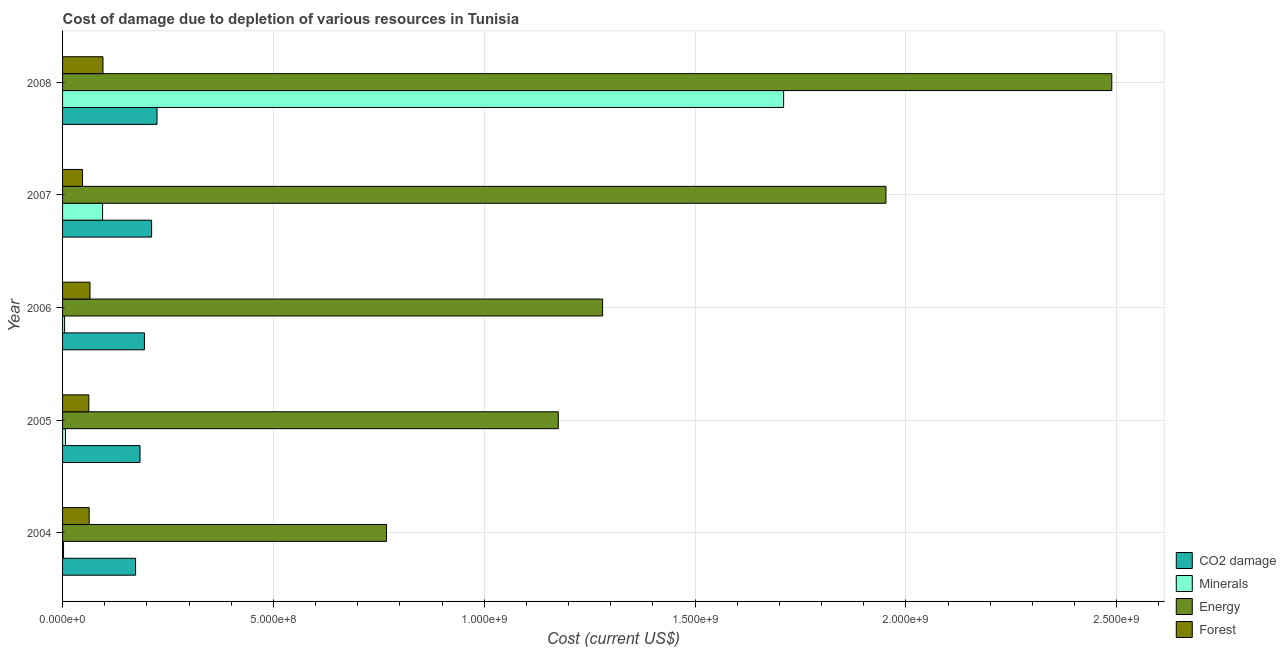How many groups of bars are there?
Offer a terse response. 5. Are the number of bars per tick equal to the number of legend labels?
Provide a short and direct response. Yes. Are the number of bars on each tick of the Y-axis equal?
Provide a succinct answer. Yes. What is the cost of damage due to depletion of coal in 2007?
Provide a short and direct response. 2.11e+08. Across all years, what is the maximum cost of damage due to depletion of forests?
Offer a very short reply. 9.59e+07. Across all years, what is the minimum cost of damage due to depletion of energy?
Offer a very short reply. 7.68e+08. What is the total cost of damage due to depletion of forests in the graph?
Provide a succinct answer. 3.34e+08. What is the difference between the cost of damage due to depletion of forests in 2005 and that in 2007?
Your answer should be compact. 1.49e+07. What is the difference between the cost of damage due to depletion of energy in 2005 and the cost of damage due to depletion of minerals in 2004?
Offer a terse response. 1.17e+09. What is the average cost of damage due to depletion of coal per year?
Your answer should be very brief. 1.97e+08. In the year 2004, what is the difference between the cost of damage due to depletion of forests and cost of damage due to depletion of minerals?
Offer a very short reply. 6.08e+07. In how many years, is the cost of damage due to depletion of forests greater than 700000000 US$?
Provide a short and direct response. 0. What is the ratio of the cost of damage due to depletion of coal in 2004 to that in 2006?
Your answer should be very brief. 0.89. Is the cost of damage due to depletion of coal in 2004 less than that in 2006?
Your answer should be compact. Yes. Is the difference between the cost of damage due to depletion of minerals in 2006 and 2008 greater than the difference between the cost of damage due to depletion of coal in 2006 and 2008?
Offer a terse response. No. What is the difference between the highest and the second highest cost of damage due to depletion of forests?
Provide a succinct answer. 3.08e+07. What is the difference between the highest and the lowest cost of damage due to depletion of coal?
Provide a short and direct response. 5.08e+07. In how many years, is the cost of damage due to depletion of forests greater than the average cost of damage due to depletion of forests taken over all years?
Keep it short and to the point. 1. Is the sum of the cost of damage due to depletion of coal in 2006 and 2008 greater than the maximum cost of damage due to depletion of energy across all years?
Ensure brevity in your answer.  No. Is it the case that in every year, the sum of the cost of damage due to depletion of forests and cost of damage due to depletion of energy is greater than the sum of cost of damage due to depletion of coal and cost of damage due to depletion of minerals?
Your answer should be very brief. Yes. What does the 3rd bar from the top in 2005 represents?
Provide a succinct answer. Minerals. What does the 2nd bar from the bottom in 2007 represents?
Offer a terse response. Minerals. How many bars are there?
Provide a short and direct response. 20. What is the title of the graph?
Provide a short and direct response. Cost of damage due to depletion of various resources in Tunisia . What is the label or title of the X-axis?
Keep it short and to the point. Cost (current US$). What is the label or title of the Y-axis?
Give a very brief answer. Year. What is the Cost (current US$) in CO2 damage in 2004?
Give a very brief answer. 1.73e+08. What is the Cost (current US$) of Minerals in 2004?
Your answer should be compact. 2.32e+06. What is the Cost (current US$) of Energy in 2004?
Your answer should be compact. 7.68e+08. What is the Cost (current US$) in Forest in 2004?
Offer a terse response. 6.31e+07. What is the Cost (current US$) in CO2 damage in 2005?
Make the answer very short. 1.84e+08. What is the Cost (current US$) of Minerals in 2005?
Provide a succinct answer. 6.94e+06. What is the Cost (current US$) in Energy in 2005?
Make the answer very short. 1.18e+09. What is the Cost (current US$) in Forest in 2005?
Offer a very short reply. 6.23e+07. What is the Cost (current US$) in CO2 damage in 2006?
Your answer should be very brief. 1.94e+08. What is the Cost (current US$) of Minerals in 2006?
Your answer should be compact. 4.85e+06. What is the Cost (current US$) of Energy in 2006?
Provide a succinct answer. 1.28e+09. What is the Cost (current US$) of Forest in 2006?
Your answer should be very brief. 6.51e+07. What is the Cost (current US$) of CO2 damage in 2007?
Offer a terse response. 2.11e+08. What is the Cost (current US$) in Minerals in 2007?
Give a very brief answer. 9.48e+07. What is the Cost (current US$) in Energy in 2007?
Offer a very short reply. 1.95e+09. What is the Cost (current US$) in Forest in 2007?
Offer a terse response. 4.74e+07. What is the Cost (current US$) of CO2 damage in 2008?
Offer a terse response. 2.24e+08. What is the Cost (current US$) in Minerals in 2008?
Keep it short and to the point. 1.71e+09. What is the Cost (current US$) of Energy in 2008?
Ensure brevity in your answer.  2.49e+09. What is the Cost (current US$) of Forest in 2008?
Provide a short and direct response. 9.59e+07. Across all years, what is the maximum Cost (current US$) of CO2 damage?
Give a very brief answer. 2.24e+08. Across all years, what is the maximum Cost (current US$) in Minerals?
Provide a succinct answer. 1.71e+09. Across all years, what is the maximum Cost (current US$) in Energy?
Offer a very short reply. 2.49e+09. Across all years, what is the maximum Cost (current US$) of Forest?
Provide a short and direct response. 9.59e+07. Across all years, what is the minimum Cost (current US$) of CO2 damage?
Offer a very short reply. 1.73e+08. Across all years, what is the minimum Cost (current US$) in Minerals?
Your response must be concise. 2.32e+06. Across all years, what is the minimum Cost (current US$) in Energy?
Offer a terse response. 7.68e+08. Across all years, what is the minimum Cost (current US$) in Forest?
Ensure brevity in your answer.  4.74e+07. What is the total Cost (current US$) of CO2 damage in the graph?
Ensure brevity in your answer.  9.86e+08. What is the total Cost (current US$) in Minerals in the graph?
Provide a short and direct response. 1.82e+09. What is the total Cost (current US$) of Energy in the graph?
Give a very brief answer. 7.67e+09. What is the total Cost (current US$) in Forest in the graph?
Your answer should be compact. 3.34e+08. What is the difference between the Cost (current US$) in CO2 damage in 2004 and that in 2005?
Offer a very short reply. -1.05e+07. What is the difference between the Cost (current US$) in Minerals in 2004 and that in 2005?
Provide a short and direct response. -4.63e+06. What is the difference between the Cost (current US$) of Energy in 2004 and that in 2005?
Offer a terse response. -4.07e+08. What is the difference between the Cost (current US$) of Forest in 2004 and that in 2005?
Make the answer very short. 8.33e+05. What is the difference between the Cost (current US$) of CO2 damage in 2004 and that in 2006?
Offer a terse response. -2.09e+07. What is the difference between the Cost (current US$) of Minerals in 2004 and that in 2006?
Keep it short and to the point. -2.53e+06. What is the difference between the Cost (current US$) of Energy in 2004 and that in 2006?
Keep it short and to the point. -5.13e+08. What is the difference between the Cost (current US$) in Forest in 2004 and that in 2006?
Keep it short and to the point. -1.98e+06. What is the difference between the Cost (current US$) in CO2 damage in 2004 and that in 2007?
Your response must be concise. -3.80e+07. What is the difference between the Cost (current US$) in Minerals in 2004 and that in 2007?
Provide a succinct answer. -9.25e+07. What is the difference between the Cost (current US$) of Energy in 2004 and that in 2007?
Offer a very short reply. -1.18e+09. What is the difference between the Cost (current US$) in Forest in 2004 and that in 2007?
Your answer should be compact. 1.57e+07. What is the difference between the Cost (current US$) of CO2 damage in 2004 and that in 2008?
Your answer should be very brief. -5.08e+07. What is the difference between the Cost (current US$) of Minerals in 2004 and that in 2008?
Offer a very short reply. -1.71e+09. What is the difference between the Cost (current US$) of Energy in 2004 and that in 2008?
Make the answer very short. -1.72e+09. What is the difference between the Cost (current US$) in Forest in 2004 and that in 2008?
Your answer should be compact. -3.28e+07. What is the difference between the Cost (current US$) in CO2 damage in 2005 and that in 2006?
Your answer should be very brief. -1.04e+07. What is the difference between the Cost (current US$) in Minerals in 2005 and that in 2006?
Ensure brevity in your answer.  2.10e+06. What is the difference between the Cost (current US$) in Energy in 2005 and that in 2006?
Ensure brevity in your answer.  -1.05e+08. What is the difference between the Cost (current US$) in Forest in 2005 and that in 2006?
Ensure brevity in your answer.  -2.81e+06. What is the difference between the Cost (current US$) in CO2 damage in 2005 and that in 2007?
Your answer should be very brief. -2.75e+07. What is the difference between the Cost (current US$) in Minerals in 2005 and that in 2007?
Make the answer very short. -8.79e+07. What is the difference between the Cost (current US$) of Energy in 2005 and that in 2007?
Give a very brief answer. -7.77e+08. What is the difference between the Cost (current US$) of Forest in 2005 and that in 2007?
Give a very brief answer. 1.49e+07. What is the difference between the Cost (current US$) of CO2 damage in 2005 and that in 2008?
Keep it short and to the point. -4.03e+07. What is the difference between the Cost (current US$) of Minerals in 2005 and that in 2008?
Offer a terse response. -1.70e+09. What is the difference between the Cost (current US$) in Energy in 2005 and that in 2008?
Provide a short and direct response. -1.31e+09. What is the difference between the Cost (current US$) of Forest in 2005 and that in 2008?
Give a very brief answer. -3.36e+07. What is the difference between the Cost (current US$) of CO2 damage in 2006 and that in 2007?
Give a very brief answer. -1.71e+07. What is the difference between the Cost (current US$) in Minerals in 2006 and that in 2007?
Keep it short and to the point. -9.00e+07. What is the difference between the Cost (current US$) in Energy in 2006 and that in 2007?
Give a very brief answer. -6.72e+08. What is the difference between the Cost (current US$) in Forest in 2006 and that in 2007?
Provide a short and direct response. 1.77e+07. What is the difference between the Cost (current US$) in CO2 damage in 2006 and that in 2008?
Ensure brevity in your answer.  -2.99e+07. What is the difference between the Cost (current US$) in Minerals in 2006 and that in 2008?
Make the answer very short. -1.71e+09. What is the difference between the Cost (current US$) in Energy in 2006 and that in 2008?
Offer a very short reply. -1.21e+09. What is the difference between the Cost (current US$) in Forest in 2006 and that in 2008?
Provide a short and direct response. -3.08e+07. What is the difference between the Cost (current US$) of CO2 damage in 2007 and that in 2008?
Make the answer very short. -1.29e+07. What is the difference between the Cost (current US$) in Minerals in 2007 and that in 2008?
Your answer should be very brief. -1.62e+09. What is the difference between the Cost (current US$) of Energy in 2007 and that in 2008?
Offer a very short reply. -5.36e+08. What is the difference between the Cost (current US$) of Forest in 2007 and that in 2008?
Your answer should be very brief. -4.85e+07. What is the difference between the Cost (current US$) of CO2 damage in 2004 and the Cost (current US$) of Minerals in 2005?
Give a very brief answer. 1.66e+08. What is the difference between the Cost (current US$) in CO2 damage in 2004 and the Cost (current US$) in Energy in 2005?
Make the answer very short. -1.00e+09. What is the difference between the Cost (current US$) of CO2 damage in 2004 and the Cost (current US$) of Forest in 2005?
Provide a short and direct response. 1.11e+08. What is the difference between the Cost (current US$) in Minerals in 2004 and the Cost (current US$) in Energy in 2005?
Provide a succinct answer. -1.17e+09. What is the difference between the Cost (current US$) in Minerals in 2004 and the Cost (current US$) in Forest in 2005?
Provide a short and direct response. -5.99e+07. What is the difference between the Cost (current US$) of Energy in 2004 and the Cost (current US$) of Forest in 2005?
Give a very brief answer. 7.06e+08. What is the difference between the Cost (current US$) of CO2 damage in 2004 and the Cost (current US$) of Minerals in 2006?
Your answer should be compact. 1.68e+08. What is the difference between the Cost (current US$) of CO2 damage in 2004 and the Cost (current US$) of Energy in 2006?
Offer a very short reply. -1.11e+09. What is the difference between the Cost (current US$) in CO2 damage in 2004 and the Cost (current US$) in Forest in 2006?
Offer a very short reply. 1.08e+08. What is the difference between the Cost (current US$) in Minerals in 2004 and the Cost (current US$) in Energy in 2006?
Provide a succinct answer. -1.28e+09. What is the difference between the Cost (current US$) of Minerals in 2004 and the Cost (current US$) of Forest in 2006?
Your answer should be very brief. -6.27e+07. What is the difference between the Cost (current US$) of Energy in 2004 and the Cost (current US$) of Forest in 2006?
Your response must be concise. 7.03e+08. What is the difference between the Cost (current US$) in CO2 damage in 2004 and the Cost (current US$) in Minerals in 2007?
Provide a short and direct response. 7.84e+07. What is the difference between the Cost (current US$) of CO2 damage in 2004 and the Cost (current US$) of Energy in 2007?
Your answer should be compact. -1.78e+09. What is the difference between the Cost (current US$) in CO2 damage in 2004 and the Cost (current US$) in Forest in 2007?
Make the answer very short. 1.26e+08. What is the difference between the Cost (current US$) of Minerals in 2004 and the Cost (current US$) of Energy in 2007?
Keep it short and to the point. -1.95e+09. What is the difference between the Cost (current US$) in Minerals in 2004 and the Cost (current US$) in Forest in 2007?
Make the answer very short. -4.51e+07. What is the difference between the Cost (current US$) in Energy in 2004 and the Cost (current US$) in Forest in 2007?
Your answer should be very brief. 7.21e+08. What is the difference between the Cost (current US$) of CO2 damage in 2004 and the Cost (current US$) of Minerals in 2008?
Provide a short and direct response. -1.54e+09. What is the difference between the Cost (current US$) of CO2 damage in 2004 and the Cost (current US$) of Energy in 2008?
Your response must be concise. -2.32e+09. What is the difference between the Cost (current US$) in CO2 damage in 2004 and the Cost (current US$) in Forest in 2008?
Offer a terse response. 7.73e+07. What is the difference between the Cost (current US$) of Minerals in 2004 and the Cost (current US$) of Energy in 2008?
Provide a succinct answer. -2.49e+09. What is the difference between the Cost (current US$) of Minerals in 2004 and the Cost (current US$) of Forest in 2008?
Your answer should be compact. -9.35e+07. What is the difference between the Cost (current US$) of Energy in 2004 and the Cost (current US$) of Forest in 2008?
Offer a terse response. 6.72e+08. What is the difference between the Cost (current US$) of CO2 damage in 2005 and the Cost (current US$) of Minerals in 2006?
Offer a very short reply. 1.79e+08. What is the difference between the Cost (current US$) in CO2 damage in 2005 and the Cost (current US$) in Energy in 2006?
Keep it short and to the point. -1.10e+09. What is the difference between the Cost (current US$) of CO2 damage in 2005 and the Cost (current US$) of Forest in 2006?
Make the answer very short. 1.19e+08. What is the difference between the Cost (current US$) of Minerals in 2005 and the Cost (current US$) of Energy in 2006?
Offer a terse response. -1.27e+09. What is the difference between the Cost (current US$) in Minerals in 2005 and the Cost (current US$) in Forest in 2006?
Keep it short and to the point. -5.81e+07. What is the difference between the Cost (current US$) of Energy in 2005 and the Cost (current US$) of Forest in 2006?
Make the answer very short. 1.11e+09. What is the difference between the Cost (current US$) of CO2 damage in 2005 and the Cost (current US$) of Minerals in 2007?
Keep it short and to the point. 8.88e+07. What is the difference between the Cost (current US$) in CO2 damage in 2005 and the Cost (current US$) in Energy in 2007?
Offer a terse response. -1.77e+09. What is the difference between the Cost (current US$) in CO2 damage in 2005 and the Cost (current US$) in Forest in 2007?
Ensure brevity in your answer.  1.36e+08. What is the difference between the Cost (current US$) in Minerals in 2005 and the Cost (current US$) in Energy in 2007?
Give a very brief answer. -1.95e+09. What is the difference between the Cost (current US$) of Minerals in 2005 and the Cost (current US$) of Forest in 2007?
Your answer should be very brief. -4.04e+07. What is the difference between the Cost (current US$) of Energy in 2005 and the Cost (current US$) of Forest in 2007?
Ensure brevity in your answer.  1.13e+09. What is the difference between the Cost (current US$) in CO2 damage in 2005 and the Cost (current US$) in Minerals in 2008?
Give a very brief answer. -1.53e+09. What is the difference between the Cost (current US$) of CO2 damage in 2005 and the Cost (current US$) of Energy in 2008?
Offer a terse response. -2.30e+09. What is the difference between the Cost (current US$) of CO2 damage in 2005 and the Cost (current US$) of Forest in 2008?
Give a very brief answer. 8.78e+07. What is the difference between the Cost (current US$) of Minerals in 2005 and the Cost (current US$) of Energy in 2008?
Your answer should be compact. -2.48e+09. What is the difference between the Cost (current US$) of Minerals in 2005 and the Cost (current US$) of Forest in 2008?
Give a very brief answer. -8.89e+07. What is the difference between the Cost (current US$) in Energy in 2005 and the Cost (current US$) in Forest in 2008?
Your answer should be very brief. 1.08e+09. What is the difference between the Cost (current US$) in CO2 damage in 2006 and the Cost (current US$) in Minerals in 2007?
Make the answer very short. 9.93e+07. What is the difference between the Cost (current US$) of CO2 damage in 2006 and the Cost (current US$) of Energy in 2007?
Keep it short and to the point. -1.76e+09. What is the difference between the Cost (current US$) in CO2 damage in 2006 and the Cost (current US$) in Forest in 2007?
Offer a terse response. 1.47e+08. What is the difference between the Cost (current US$) in Minerals in 2006 and the Cost (current US$) in Energy in 2007?
Provide a succinct answer. -1.95e+09. What is the difference between the Cost (current US$) of Minerals in 2006 and the Cost (current US$) of Forest in 2007?
Keep it short and to the point. -4.25e+07. What is the difference between the Cost (current US$) of Energy in 2006 and the Cost (current US$) of Forest in 2007?
Make the answer very short. 1.23e+09. What is the difference between the Cost (current US$) in CO2 damage in 2006 and the Cost (current US$) in Minerals in 2008?
Offer a very short reply. -1.52e+09. What is the difference between the Cost (current US$) in CO2 damage in 2006 and the Cost (current US$) in Energy in 2008?
Ensure brevity in your answer.  -2.29e+09. What is the difference between the Cost (current US$) in CO2 damage in 2006 and the Cost (current US$) in Forest in 2008?
Offer a very short reply. 9.82e+07. What is the difference between the Cost (current US$) of Minerals in 2006 and the Cost (current US$) of Energy in 2008?
Make the answer very short. -2.48e+09. What is the difference between the Cost (current US$) of Minerals in 2006 and the Cost (current US$) of Forest in 2008?
Keep it short and to the point. -9.10e+07. What is the difference between the Cost (current US$) of Energy in 2006 and the Cost (current US$) of Forest in 2008?
Your response must be concise. 1.18e+09. What is the difference between the Cost (current US$) of CO2 damage in 2007 and the Cost (current US$) of Minerals in 2008?
Provide a succinct answer. -1.50e+09. What is the difference between the Cost (current US$) of CO2 damage in 2007 and the Cost (current US$) of Energy in 2008?
Your response must be concise. -2.28e+09. What is the difference between the Cost (current US$) in CO2 damage in 2007 and the Cost (current US$) in Forest in 2008?
Your response must be concise. 1.15e+08. What is the difference between the Cost (current US$) in Minerals in 2007 and the Cost (current US$) in Energy in 2008?
Your response must be concise. -2.39e+09. What is the difference between the Cost (current US$) in Minerals in 2007 and the Cost (current US$) in Forest in 2008?
Provide a succinct answer. -1.02e+06. What is the difference between the Cost (current US$) of Energy in 2007 and the Cost (current US$) of Forest in 2008?
Your answer should be compact. 1.86e+09. What is the average Cost (current US$) in CO2 damage per year?
Provide a short and direct response. 1.97e+08. What is the average Cost (current US$) in Minerals per year?
Offer a very short reply. 3.64e+08. What is the average Cost (current US$) in Energy per year?
Offer a very short reply. 1.53e+09. What is the average Cost (current US$) in Forest per year?
Your answer should be very brief. 6.67e+07. In the year 2004, what is the difference between the Cost (current US$) of CO2 damage and Cost (current US$) of Minerals?
Ensure brevity in your answer.  1.71e+08. In the year 2004, what is the difference between the Cost (current US$) of CO2 damage and Cost (current US$) of Energy?
Provide a short and direct response. -5.95e+08. In the year 2004, what is the difference between the Cost (current US$) in CO2 damage and Cost (current US$) in Forest?
Make the answer very short. 1.10e+08. In the year 2004, what is the difference between the Cost (current US$) in Minerals and Cost (current US$) in Energy?
Give a very brief answer. -7.66e+08. In the year 2004, what is the difference between the Cost (current US$) in Minerals and Cost (current US$) in Forest?
Provide a short and direct response. -6.08e+07. In the year 2004, what is the difference between the Cost (current US$) of Energy and Cost (current US$) of Forest?
Give a very brief answer. 7.05e+08. In the year 2005, what is the difference between the Cost (current US$) of CO2 damage and Cost (current US$) of Minerals?
Your response must be concise. 1.77e+08. In the year 2005, what is the difference between the Cost (current US$) in CO2 damage and Cost (current US$) in Energy?
Provide a short and direct response. -9.92e+08. In the year 2005, what is the difference between the Cost (current US$) in CO2 damage and Cost (current US$) in Forest?
Make the answer very short. 1.21e+08. In the year 2005, what is the difference between the Cost (current US$) of Minerals and Cost (current US$) of Energy?
Provide a short and direct response. -1.17e+09. In the year 2005, what is the difference between the Cost (current US$) of Minerals and Cost (current US$) of Forest?
Ensure brevity in your answer.  -5.53e+07. In the year 2005, what is the difference between the Cost (current US$) of Energy and Cost (current US$) of Forest?
Keep it short and to the point. 1.11e+09. In the year 2006, what is the difference between the Cost (current US$) in CO2 damage and Cost (current US$) in Minerals?
Offer a very short reply. 1.89e+08. In the year 2006, what is the difference between the Cost (current US$) in CO2 damage and Cost (current US$) in Energy?
Provide a short and direct response. -1.09e+09. In the year 2006, what is the difference between the Cost (current US$) of CO2 damage and Cost (current US$) of Forest?
Provide a succinct answer. 1.29e+08. In the year 2006, what is the difference between the Cost (current US$) in Minerals and Cost (current US$) in Energy?
Provide a succinct answer. -1.28e+09. In the year 2006, what is the difference between the Cost (current US$) in Minerals and Cost (current US$) in Forest?
Give a very brief answer. -6.02e+07. In the year 2006, what is the difference between the Cost (current US$) of Energy and Cost (current US$) of Forest?
Provide a short and direct response. 1.22e+09. In the year 2007, what is the difference between the Cost (current US$) in CO2 damage and Cost (current US$) in Minerals?
Give a very brief answer. 1.16e+08. In the year 2007, what is the difference between the Cost (current US$) in CO2 damage and Cost (current US$) in Energy?
Your response must be concise. -1.74e+09. In the year 2007, what is the difference between the Cost (current US$) of CO2 damage and Cost (current US$) of Forest?
Your answer should be compact. 1.64e+08. In the year 2007, what is the difference between the Cost (current US$) in Minerals and Cost (current US$) in Energy?
Offer a very short reply. -1.86e+09. In the year 2007, what is the difference between the Cost (current US$) of Minerals and Cost (current US$) of Forest?
Give a very brief answer. 4.75e+07. In the year 2007, what is the difference between the Cost (current US$) of Energy and Cost (current US$) of Forest?
Provide a short and direct response. 1.91e+09. In the year 2008, what is the difference between the Cost (current US$) in CO2 damage and Cost (current US$) in Minerals?
Offer a terse response. -1.49e+09. In the year 2008, what is the difference between the Cost (current US$) in CO2 damage and Cost (current US$) in Energy?
Offer a very short reply. -2.26e+09. In the year 2008, what is the difference between the Cost (current US$) in CO2 damage and Cost (current US$) in Forest?
Ensure brevity in your answer.  1.28e+08. In the year 2008, what is the difference between the Cost (current US$) of Minerals and Cost (current US$) of Energy?
Keep it short and to the point. -7.78e+08. In the year 2008, what is the difference between the Cost (current US$) of Minerals and Cost (current US$) of Forest?
Offer a terse response. 1.61e+09. In the year 2008, what is the difference between the Cost (current US$) of Energy and Cost (current US$) of Forest?
Keep it short and to the point. 2.39e+09. What is the ratio of the Cost (current US$) in CO2 damage in 2004 to that in 2005?
Your response must be concise. 0.94. What is the ratio of the Cost (current US$) of Minerals in 2004 to that in 2005?
Keep it short and to the point. 0.33. What is the ratio of the Cost (current US$) in Energy in 2004 to that in 2005?
Provide a succinct answer. 0.65. What is the ratio of the Cost (current US$) of Forest in 2004 to that in 2005?
Ensure brevity in your answer.  1.01. What is the ratio of the Cost (current US$) in CO2 damage in 2004 to that in 2006?
Make the answer very short. 0.89. What is the ratio of the Cost (current US$) in Minerals in 2004 to that in 2006?
Offer a very short reply. 0.48. What is the ratio of the Cost (current US$) of Energy in 2004 to that in 2006?
Your answer should be compact. 0.6. What is the ratio of the Cost (current US$) in Forest in 2004 to that in 2006?
Provide a succinct answer. 0.97. What is the ratio of the Cost (current US$) in CO2 damage in 2004 to that in 2007?
Your response must be concise. 0.82. What is the ratio of the Cost (current US$) in Minerals in 2004 to that in 2007?
Your answer should be very brief. 0.02. What is the ratio of the Cost (current US$) of Energy in 2004 to that in 2007?
Offer a very short reply. 0.39. What is the ratio of the Cost (current US$) in Forest in 2004 to that in 2007?
Your response must be concise. 1.33. What is the ratio of the Cost (current US$) in CO2 damage in 2004 to that in 2008?
Make the answer very short. 0.77. What is the ratio of the Cost (current US$) of Minerals in 2004 to that in 2008?
Provide a short and direct response. 0. What is the ratio of the Cost (current US$) of Energy in 2004 to that in 2008?
Your answer should be compact. 0.31. What is the ratio of the Cost (current US$) of Forest in 2004 to that in 2008?
Your answer should be compact. 0.66. What is the ratio of the Cost (current US$) of CO2 damage in 2005 to that in 2006?
Give a very brief answer. 0.95. What is the ratio of the Cost (current US$) in Minerals in 2005 to that in 2006?
Keep it short and to the point. 1.43. What is the ratio of the Cost (current US$) in Energy in 2005 to that in 2006?
Your answer should be compact. 0.92. What is the ratio of the Cost (current US$) of Forest in 2005 to that in 2006?
Keep it short and to the point. 0.96. What is the ratio of the Cost (current US$) of CO2 damage in 2005 to that in 2007?
Offer a very short reply. 0.87. What is the ratio of the Cost (current US$) of Minerals in 2005 to that in 2007?
Offer a terse response. 0.07. What is the ratio of the Cost (current US$) in Energy in 2005 to that in 2007?
Give a very brief answer. 0.6. What is the ratio of the Cost (current US$) in Forest in 2005 to that in 2007?
Offer a terse response. 1.31. What is the ratio of the Cost (current US$) in CO2 damage in 2005 to that in 2008?
Make the answer very short. 0.82. What is the ratio of the Cost (current US$) in Minerals in 2005 to that in 2008?
Give a very brief answer. 0. What is the ratio of the Cost (current US$) in Energy in 2005 to that in 2008?
Provide a succinct answer. 0.47. What is the ratio of the Cost (current US$) in Forest in 2005 to that in 2008?
Offer a terse response. 0.65. What is the ratio of the Cost (current US$) of CO2 damage in 2006 to that in 2007?
Keep it short and to the point. 0.92. What is the ratio of the Cost (current US$) in Minerals in 2006 to that in 2007?
Provide a short and direct response. 0.05. What is the ratio of the Cost (current US$) in Energy in 2006 to that in 2007?
Give a very brief answer. 0.66. What is the ratio of the Cost (current US$) in Forest in 2006 to that in 2007?
Your answer should be very brief. 1.37. What is the ratio of the Cost (current US$) in CO2 damage in 2006 to that in 2008?
Make the answer very short. 0.87. What is the ratio of the Cost (current US$) of Minerals in 2006 to that in 2008?
Provide a succinct answer. 0. What is the ratio of the Cost (current US$) in Energy in 2006 to that in 2008?
Give a very brief answer. 0.51. What is the ratio of the Cost (current US$) in Forest in 2006 to that in 2008?
Give a very brief answer. 0.68. What is the ratio of the Cost (current US$) in CO2 damage in 2007 to that in 2008?
Your answer should be compact. 0.94. What is the ratio of the Cost (current US$) of Minerals in 2007 to that in 2008?
Make the answer very short. 0.06. What is the ratio of the Cost (current US$) of Energy in 2007 to that in 2008?
Provide a short and direct response. 0.78. What is the ratio of the Cost (current US$) of Forest in 2007 to that in 2008?
Your answer should be very brief. 0.49. What is the difference between the highest and the second highest Cost (current US$) in CO2 damage?
Offer a very short reply. 1.29e+07. What is the difference between the highest and the second highest Cost (current US$) of Minerals?
Make the answer very short. 1.62e+09. What is the difference between the highest and the second highest Cost (current US$) in Energy?
Give a very brief answer. 5.36e+08. What is the difference between the highest and the second highest Cost (current US$) in Forest?
Ensure brevity in your answer.  3.08e+07. What is the difference between the highest and the lowest Cost (current US$) in CO2 damage?
Offer a terse response. 5.08e+07. What is the difference between the highest and the lowest Cost (current US$) in Minerals?
Provide a succinct answer. 1.71e+09. What is the difference between the highest and the lowest Cost (current US$) in Energy?
Provide a succinct answer. 1.72e+09. What is the difference between the highest and the lowest Cost (current US$) in Forest?
Offer a terse response. 4.85e+07. 